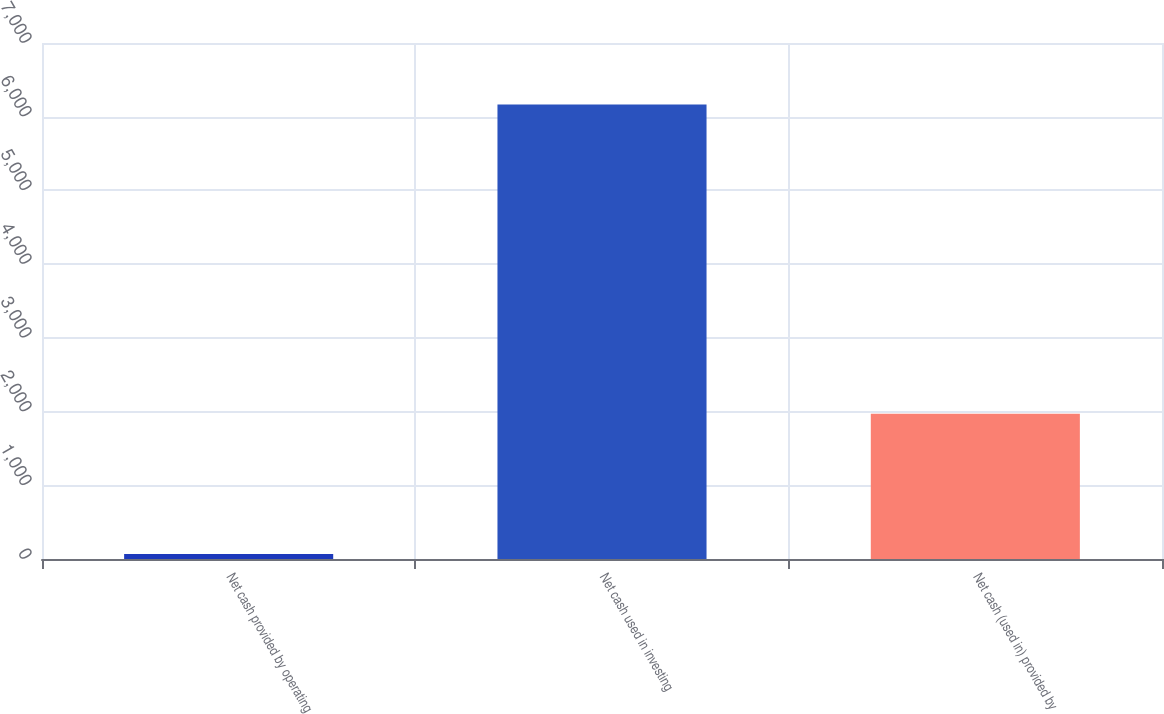<chart> <loc_0><loc_0><loc_500><loc_500><bar_chart><fcel>Net cash provided by operating<fcel>Net cash used in investing<fcel>Net cash (used in) provided by<nl><fcel>68<fcel>6166<fcel>1969<nl></chart> 